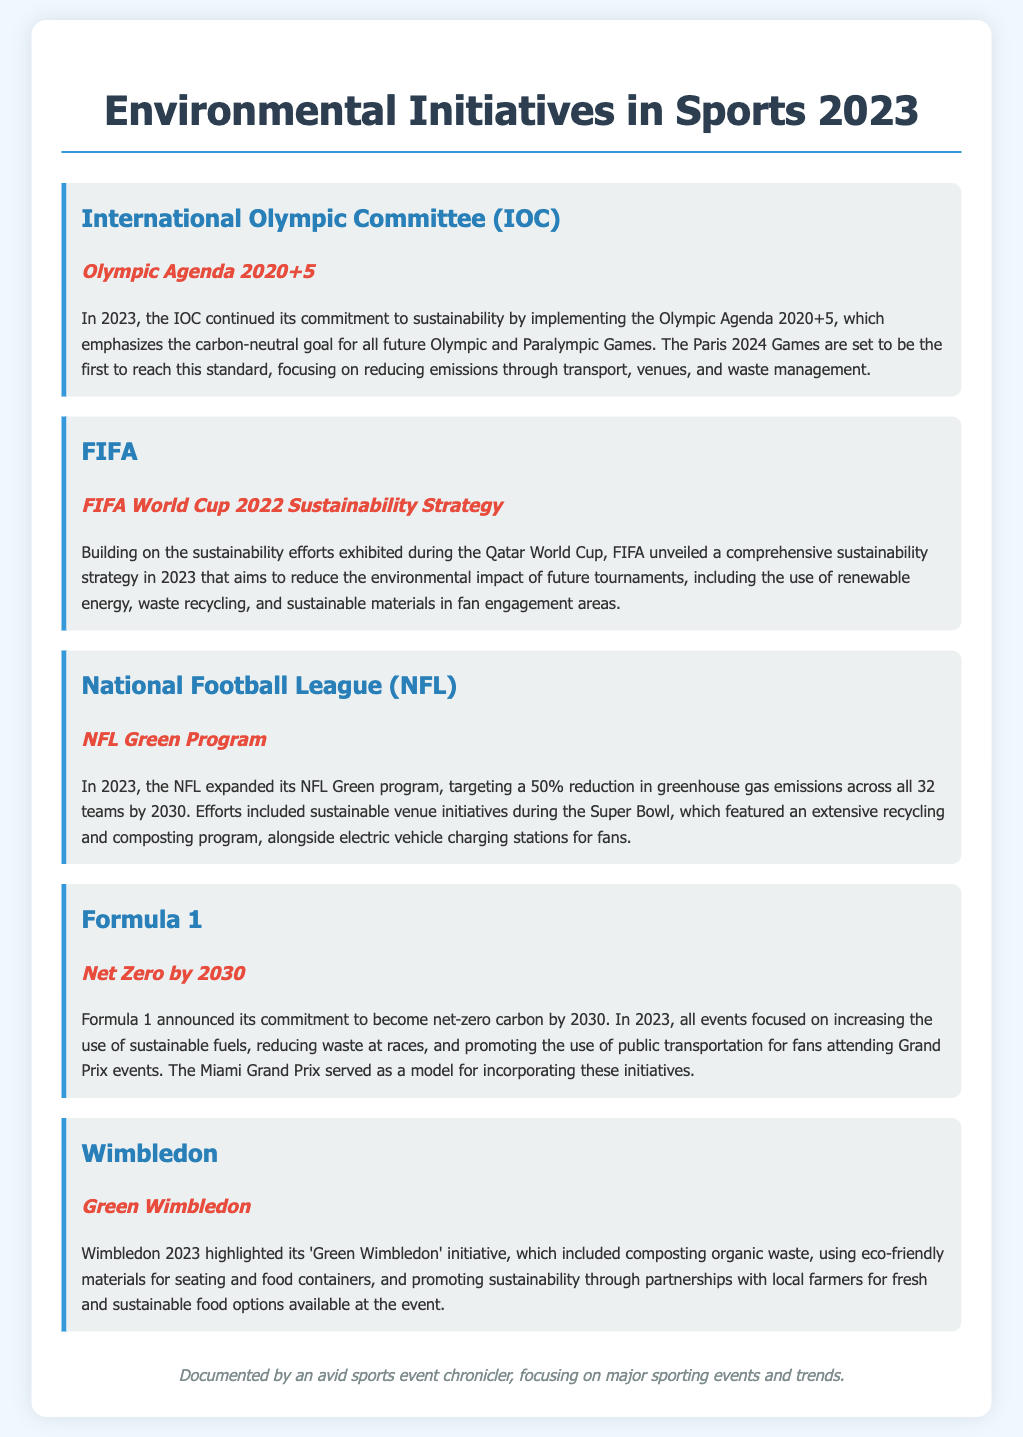what is the focus of the Olympic Agenda 2020+5? The Olympic Agenda 2020+5 emphasizes the carbon-neutral goal for all future Olympic and Paralympic Games.
Answer: carbon-neutral goal which major event is set to be the first to reach the carbon-neutral standard? The document states that the Paris 2024 Games are set to be the first to reach this standard.
Answer: Paris 2024 Games what sustainability initiative did FIFA unveil in 2023? FIFA unveiled a comprehensive sustainability strategy in 2023 to reduce the environmental impact of future tournaments.
Answer: sustainability strategy what is the target reduction in greenhouse gas emissions by NFL for 2030? The NFL is targeting a 50% reduction in greenhouse gas emissions by 2030.
Answer: 50% what key component was included in the NFL's Super Bowl sustainability efforts? The NFL featured an extensive recycling and composting program during the Super Bowl.
Answer: recycling and composting program what is the commitment of Formula 1 regarding carbon emissions by 2030? Formula 1 announced its commitment to become net-zero carbon by 2030.
Answer: net-zero carbon what initiative was highlighted during Wimbledon 2023? Wimbledon highlighted its 'Green Wimbledon' initiative in 2023.
Answer: Green Wimbledon which Grand Prix served as a model for incorporating sustainable initiatives? The Miami Grand Prix served as a model for incorporating sustainable initiatives.
Answer: Miami Grand Prix 